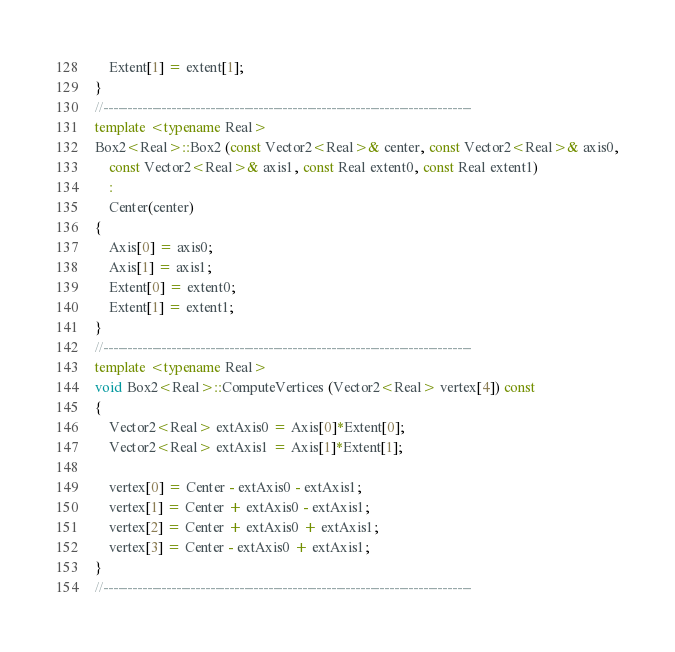Convert code to text. <code><loc_0><loc_0><loc_500><loc_500><_C++_>    Extent[1] = extent[1];
}
//----------------------------------------------------------------------------
template <typename Real>
Box2<Real>::Box2 (const Vector2<Real>& center, const Vector2<Real>& axis0,
    const Vector2<Real>& axis1, const Real extent0, const Real extent1)
    :
    Center(center)
{
    Axis[0] = axis0;
    Axis[1] = axis1;
    Extent[0] = extent0;
    Extent[1] = extent1;
}
//----------------------------------------------------------------------------
template <typename Real>
void Box2<Real>::ComputeVertices (Vector2<Real> vertex[4]) const
{
    Vector2<Real> extAxis0 = Axis[0]*Extent[0];
    Vector2<Real> extAxis1 = Axis[1]*Extent[1];

    vertex[0] = Center - extAxis0 - extAxis1;
    vertex[1] = Center + extAxis0 - extAxis1;
    vertex[2] = Center + extAxis0 + extAxis1;
    vertex[3] = Center - extAxis0 + extAxis1;
}
//----------------------------------------------------------------------------
</code> 